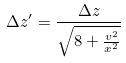<formula> <loc_0><loc_0><loc_500><loc_500>\Delta z ^ { \prime } = \frac { \Delta z } { \sqrt { 8 + \frac { v ^ { 2 } } { x ^ { 2 } } } }</formula> 